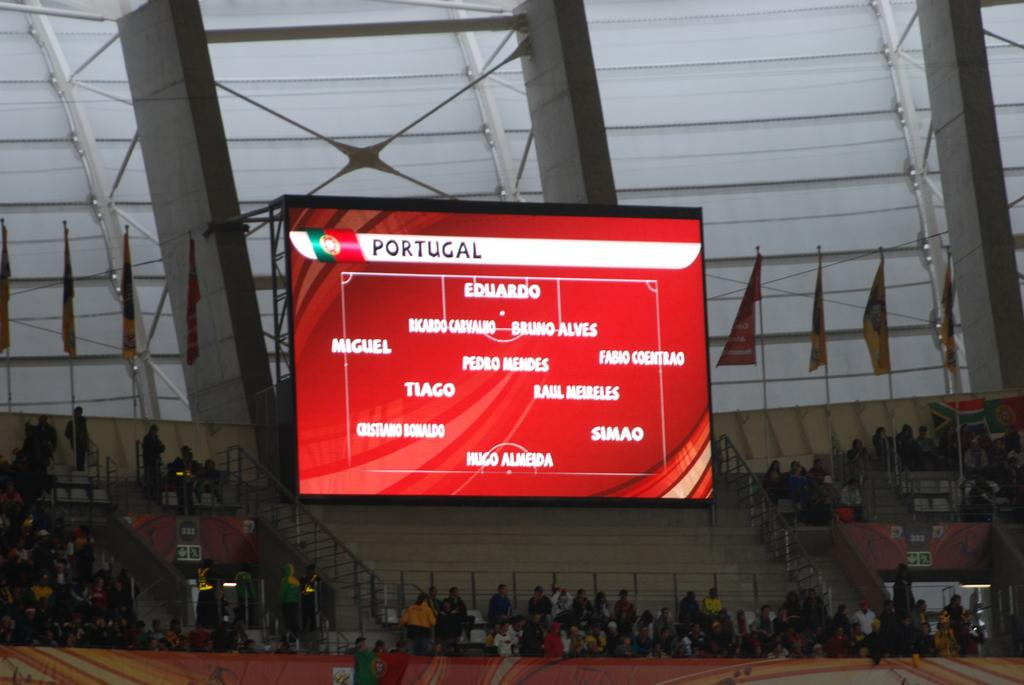<image>
Render a clear and concise summary of the photo. Portugal has eleven members participating for their team. 